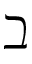Convert formula to latex. <formula><loc_0><loc_0><loc_500><loc_500>\beth</formula> 